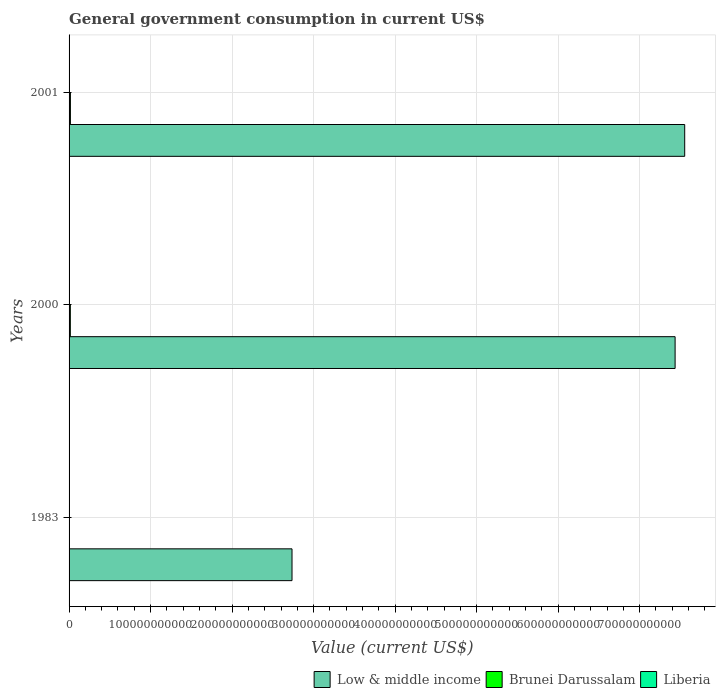Are the number of bars per tick equal to the number of legend labels?
Give a very brief answer. Yes. What is the label of the 3rd group of bars from the top?
Make the answer very short. 1983. What is the government conusmption in Low & middle income in 2000?
Offer a terse response. 7.43e+11. Across all years, what is the maximum government conusmption in Brunei Darussalam?
Make the answer very short. 1.65e+09. Across all years, what is the minimum government conusmption in Low & middle income?
Ensure brevity in your answer.  2.74e+11. In which year was the government conusmption in Brunei Darussalam minimum?
Provide a short and direct response. 1983. What is the total government conusmption in Liberia in the graph?
Your response must be concise. 2.79e+08. What is the difference between the government conusmption in Low & middle income in 1983 and that in 2000?
Keep it short and to the point. -4.70e+11. What is the difference between the government conusmption in Brunei Darussalam in 2000 and the government conusmption in Low & middle income in 2001?
Make the answer very short. -7.54e+11. What is the average government conusmption in Liberia per year?
Make the answer very short. 9.30e+07. In the year 2000, what is the difference between the government conusmption in Low & middle income and government conusmption in Brunei Darussalam?
Give a very brief answer. 7.42e+11. In how many years, is the government conusmption in Liberia greater than 720000000000 US$?
Give a very brief answer. 0. What is the ratio of the government conusmption in Brunei Darussalam in 1983 to that in 2000?
Offer a very short reply. 0.23. Is the difference between the government conusmption in Low & middle income in 2000 and 2001 greater than the difference between the government conusmption in Brunei Darussalam in 2000 and 2001?
Ensure brevity in your answer.  No. What is the difference between the highest and the second highest government conusmption in Brunei Darussalam?
Your answer should be very brief. 9.75e+07. What is the difference between the highest and the lowest government conusmption in Brunei Darussalam?
Give a very brief answer. 1.28e+09. In how many years, is the government conusmption in Low & middle income greater than the average government conusmption in Low & middle income taken over all years?
Your response must be concise. 2. Is the sum of the government conusmption in Low & middle income in 1983 and 2000 greater than the maximum government conusmption in Liberia across all years?
Make the answer very short. Yes. What does the 2nd bar from the top in 1983 represents?
Provide a succinct answer. Brunei Darussalam. What does the 3rd bar from the bottom in 2000 represents?
Make the answer very short. Liberia. How many bars are there?
Ensure brevity in your answer.  9. Are all the bars in the graph horizontal?
Provide a succinct answer. Yes. What is the difference between two consecutive major ticks on the X-axis?
Provide a short and direct response. 1.00e+11. What is the title of the graph?
Offer a terse response. General government consumption in current US$. Does "Togo" appear as one of the legend labels in the graph?
Your answer should be compact. No. What is the label or title of the X-axis?
Make the answer very short. Value (current US$). What is the label or title of the Y-axis?
Your answer should be very brief. Years. What is the Value (current US$) of Low & middle income in 1983?
Give a very brief answer. 2.74e+11. What is the Value (current US$) in Brunei Darussalam in 1983?
Ensure brevity in your answer.  3.63e+08. What is the Value (current US$) in Liberia in 1983?
Keep it short and to the point. 2.04e+08. What is the Value (current US$) of Low & middle income in 2000?
Ensure brevity in your answer.  7.43e+11. What is the Value (current US$) of Brunei Darussalam in 2000?
Make the answer very short. 1.55e+09. What is the Value (current US$) of Liberia in 2000?
Your response must be concise. 3.99e+07. What is the Value (current US$) of Low & middle income in 2001?
Give a very brief answer. 7.55e+11. What is the Value (current US$) in Brunei Darussalam in 2001?
Give a very brief answer. 1.65e+09. What is the Value (current US$) of Liberia in 2001?
Your response must be concise. 3.51e+07. Across all years, what is the maximum Value (current US$) in Low & middle income?
Keep it short and to the point. 7.55e+11. Across all years, what is the maximum Value (current US$) of Brunei Darussalam?
Provide a short and direct response. 1.65e+09. Across all years, what is the maximum Value (current US$) in Liberia?
Offer a terse response. 2.04e+08. Across all years, what is the minimum Value (current US$) in Low & middle income?
Your answer should be very brief. 2.74e+11. Across all years, what is the minimum Value (current US$) in Brunei Darussalam?
Provide a succinct answer. 3.63e+08. Across all years, what is the minimum Value (current US$) in Liberia?
Ensure brevity in your answer.  3.51e+07. What is the total Value (current US$) of Low & middle income in the graph?
Offer a terse response. 1.77e+12. What is the total Value (current US$) of Brunei Darussalam in the graph?
Keep it short and to the point. 3.56e+09. What is the total Value (current US$) of Liberia in the graph?
Make the answer very short. 2.79e+08. What is the difference between the Value (current US$) of Low & middle income in 1983 and that in 2000?
Offer a terse response. -4.70e+11. What is the difference between the Value (current US$) in Brunei Darussalam in 1983 and that in 2000?
Provide a succinct answer. -1.19e+09. What is the difference between the Value (current US$) in Liberia in 1983 and that in 2000?
Make the answer very short. 1.64e+08. What is the difference between the Value (current US$) of Low & middle income in 1983 and that in 2001?
Offer a terse response. -4.82e+11. What is the difference between the Value (current US$) of Brunei Darussalam in 1983 and that in 2001?
Provide a succinct answer. -1.28e+09. What is the difference between the Value (current US$) of Liberia in 1983 and that in 2001?
Offer a terse response. 1.69e+08. What is the difference between the Value (current US$) of Low & middle income in 2000 and that in 2001?
Ensure brevity in your answer.  -1.18e+1. What is the difference between the Value (current US$) in Brunei Darussalam in 2000 and that in 2001?
Make the answer very short. -9.75e+07. What is the difference between the Value (current US$) in Liberia in 2000 and that in 2001?
Make the answer very short. 4.77e+06. What is the difference between the Value (current US$) of Low & middle income in 1983 and the Value (current US$) of Brunei Darussalam in 2000?
Your answer should be compact. 2.72e+11. What is the difference between the Value (current US$) in Low & middle income in 1983 and the Value (current US$) in Liberia in 2000?
Offer a very short reply. 2.73e+11. What is the difference between the Value (current US$) in Brunei Darussalam in 1983 and the Value (current US$) in Liberia in 2000?
Offer a very short reply. 3.24e+08. What is the difference between the Value (current US$) of Low & middle income in 1983 and the Value (current US$) of Brunei Darussalam in 2001?
Ensure brevity in your answer.  2.72e+11. What is the difference between the Value (current US$) of Low & middle income in 1983 and the Value (current US$) of Liberia in 2001?
Your answer should be compact. 2.73e+11. What is the difference between the Value (current US$) of Brunei Darussalam in 1983 and the Value (current US$) of Liberia in 2001?
Offer a very short reply. 3.28e+08. What is the difference between the Value (current US$) of Low & middle income in 2000 and the Value (current US$) of Brunei Darussalam in 2001?
Offer a very short reply. 7.42e+11. What is the difference between the Value (current US$) of Low & middle income in 2000 and the Value (current US$) of Liberia in 2001?
Make the answer very short. 7.43e+11. What is the difference between the Value (current US$) in Brunei Darussalam in 2000 and the Value (current US$) in Liberia in 2001?
Ensure brevity in your answer.  1.51e+09. What is the average Value (current US$) in Low & middle income per year?
Offer a very short reply. 5.91e+11. What is the average Value (current US$) of Brunei Darussalam per year?
Offer a terse response. 1.19e+09. What is the average Value (current US$) of Liberia per year?
Offer a very short reply. 9.30e+07. In the year 1983, what is the difference between the Value (current US$) in Low & middle income and Value (current US$) in Brunei Darussalam?
Offer a terse response. 2.73e+11. In the year 1983, what is the difference between the Value (current US$) in Low & middle income and Value (current US$) in Liberia?
Provide a short and direct response. 2.73e+11. In the year 1983, what is the difference between the Value (current US$) in Brunei Darussalam and Value (current US$) in Liberia?
Keep it short and to the point. 1.59e+08. In the year 2000, what is the difference between the Value (current US$) of Low & middle income and Value (current US$) of Brunei Darussalam?
Your answer should be very brief. 7.42e+11. In the year 2000, what is the difference between the Value (current US$) of Low & middle income and Value (current US$) of Liberia?
Make the answer very short. 7.43e+11. In the year 2000, what is the difference between the Value (current US$) of Brunei Darussalam and Value (current US$) of Liberia?
Offer a very short reply. 1.51e+09. In the year 2001, what is the difference between the Value (current US$) in Low & middle income and Value (current US$) in Brunei Darussalam?
Offer a very short reply. 7.54e+11. In the year 2001, what is the difference between the Value (current US$) of Low & middle income and Value (current US$) of Liberia?
Your answer should be very brief. 7.55e+11. In the year 2001, what is the difference between the Value (current US$) in Brunei Darussalam and Value (current US$) in Liberia?
Provide a succinct answer. 1.61e+09. What is the ratio of the Value (current US$) of Low & middle income in 1983 to that in 2000?
Your answer should be very brief. 0.37. What is the ratio of the Value (current US$) of Brunei Darussalam in 1983 to that in 2000?
Offer a terse response. 0.23. What is the ratio of the Value (current US$) of Liberia in 1983 to that in 2000?
Make the answer very short. 5.12. What is the ratio of the Value (current US$) of Low & middle income in 1983 to that in 2001?
Your answer should be very brief. 0.36. What is the ratio of the Value (current US$) of Brunei Darussalam in 1983 to that in 2001?
Your response must be concise. 0.22. What is the ratio of the Value (current US$) in Liberia in 1983 to that in 2001?
Offer a terse response. 5.82. What is the ratio of the Value (current US$) of Low & middle income in 2000 to that in 2001?
Make the answer very short. 0.98. What is the ratio of the Value (current US$) of Brunei Darussalam in 2000 to that in 2001?
Offer a very short reply. 0.94. What is the ratio of the Value (current US$) in Liberia in 2000 to that in 2001?
Give a very brief answer. 1.14. What is the difference between the highest and the second highest Value (current US$) of Low & middle income?
Provide a succinct answer. 1.18e+1. What is the difference between the highest and the second highest Value (current US$) in Brunei Darussalam?
Your response must be concise. 9.75e+07. What is the difference between the highest and the second highest Value (current US$) of Liberia?
Your response must be concise. 1.64e+08. What is the difference between the highest and the lowest Value (current US$) in Low & middle income?
Your answer should be very brief. 4.82e+11. What is the difference between the highest and the lowest Value (current US$) in Brunei Darussalam?
Provide a succinct answer. 1.28e+09. What is the difference between the highest and the lowest Value (current US$) of Liberia?
Ensure brevity in your answer.  1.69e+08. 